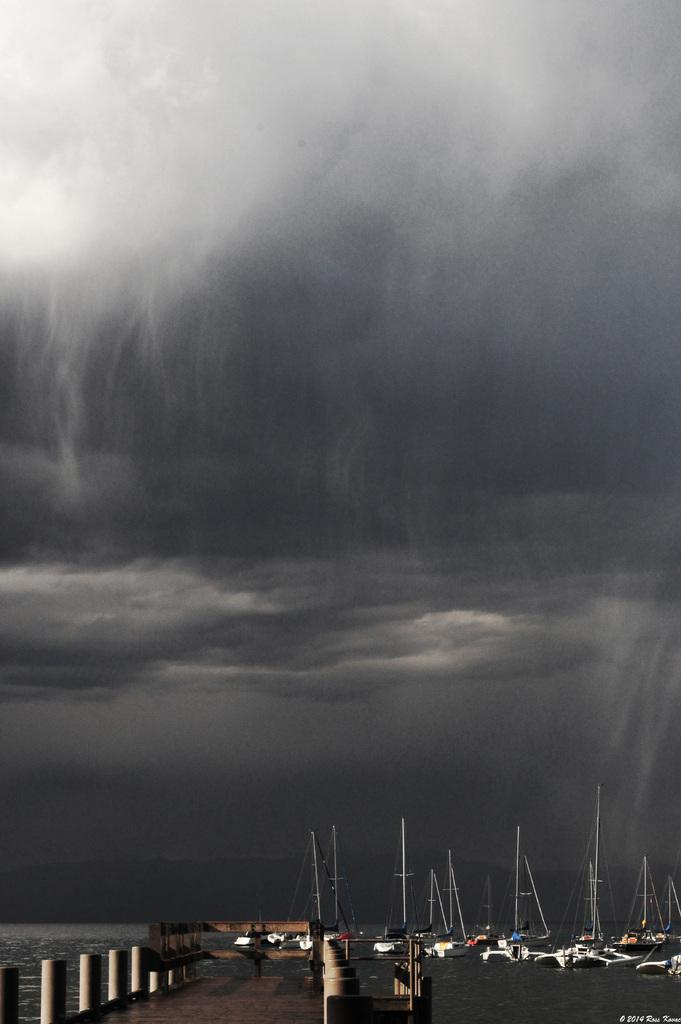What is happening on the water in the image? There are boats on the water in the image. What type of facility is present in the image? There is a boat yard in the image. What can be seen in the background of the image? The sky is visible in the background of the image. Is there any additional information or marking on the image? Yes, there is a watermark in the bottom right corner of the image. Can you tell me how many animals are taking a bath in the image? There are no animals taking a bath in the image; it features boats on the water and a boat yard. What type of loss is depicted in the image? There is no loss depicted in the image; it shows boats, a boat yard, and the sky. 